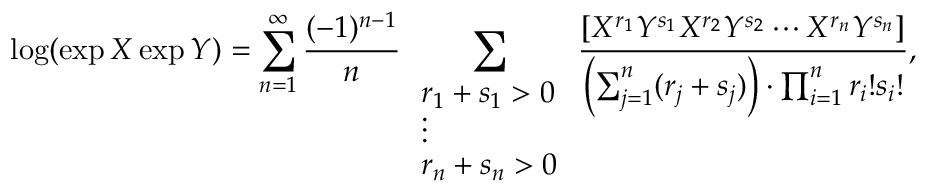<formula> <loc_0><loc_0><loc_500><loc_500>\log ( \exp X \exp Y ) = \sum _ { n = 1 } ^ { \infty } { \frac { ( - 1 ) ^ { n - 1 } } { n } } \sum _ { \begin{array} { l } { r _ { 1 } + s _ { 1 } > 0 } \\ { \vdots } \\ { r _ { n } + s _ { n } > 0 } \end{array} } { \frac { [ X ^ { r _ { 1 } } Y ^ { s _ { 1 } } X ^ { r _ { 2 } } Y ^ { s _ { 2 } } \dots m X ^ { r _ { n } } Y ^ { s _ { n } } ] } { \left ( \sum _ { j = 1 } ^ { n } ( r _ { j } + s _ { j } ) \right ) \cdot \prod _ { i = 1 } ^ { n } r _ { i } ! s _ { i } ! } } ,</formula> 